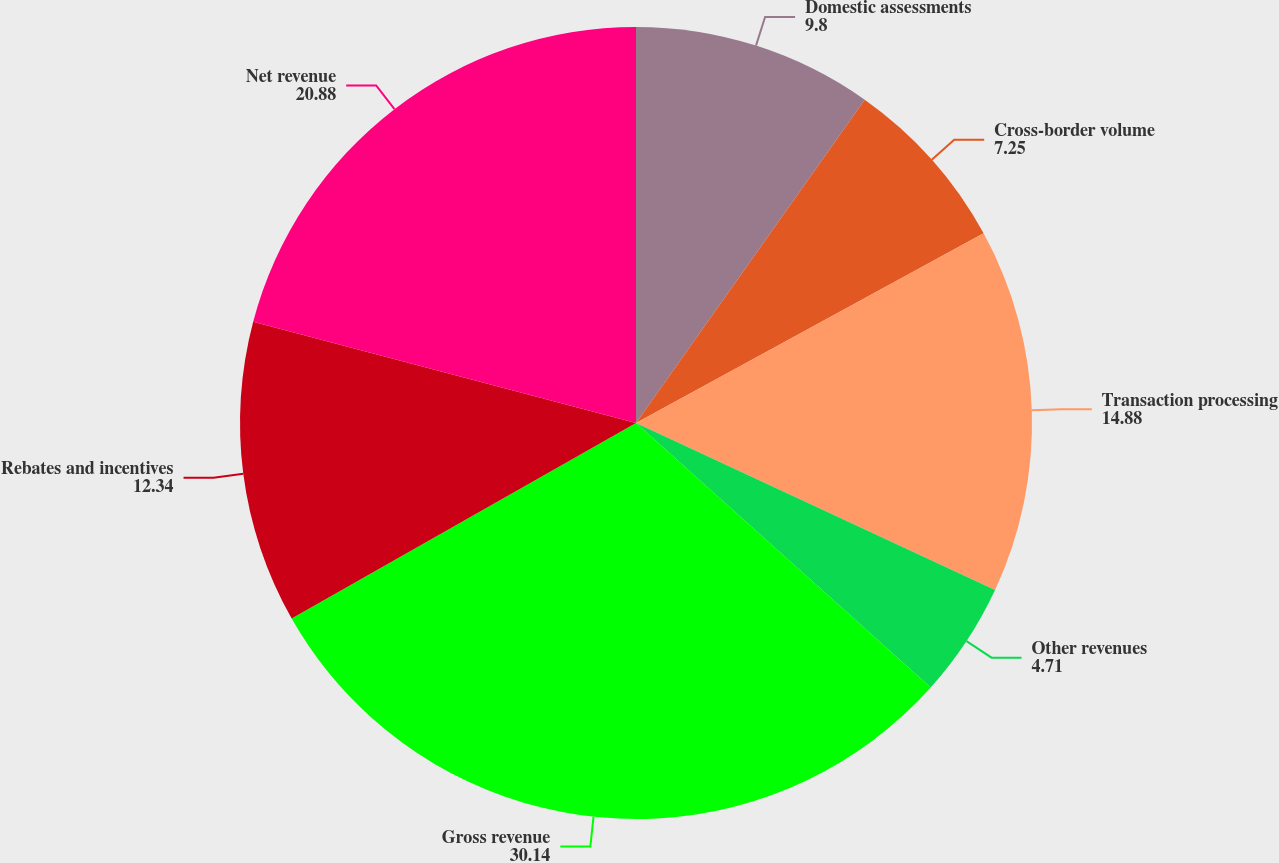Convert chart. <chart><loc_0><loc_0><loc_500><loc_500><pie_chart><fcel>Domestic assessments<fcel>Cross-border volume<fcel>Transaction processing<fcel>Other revenues<fcel>Gross revenue<fcel>Rebates and incentives<fcel>Net revenue<nl><fcel>9.8%<fcel>7.25%<fcel>14.88%<fcel>4.71%<fcel>30.14%<fcel>12.34%<fcel>20.88%<nl></chart> 